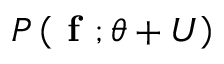<formula> <loc_0><loc_0><loc_500><loc_500>P \left ( f ; \theta + U \right )</formula> 